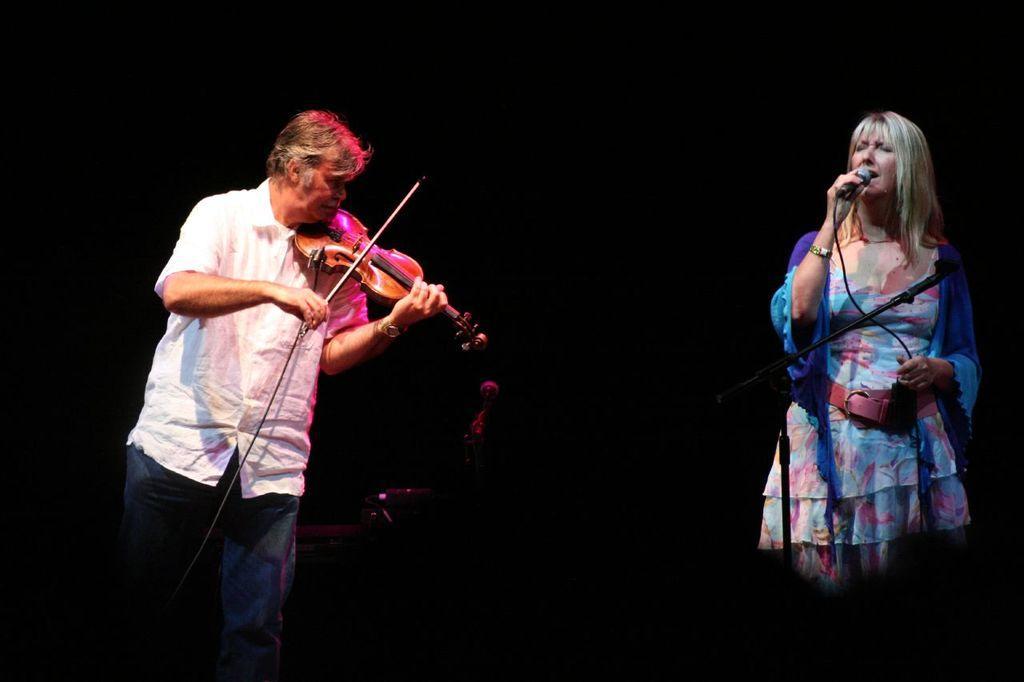Please provide a concise description of this image. This man is playing a violin with stick. This woman is singing in-front of mic. This is a mic holder. 